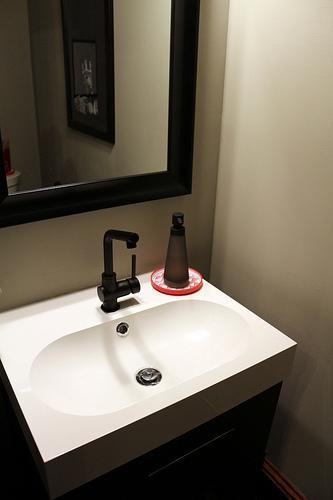How many bottles are on the sink?
Give a very brief answer. 1. 